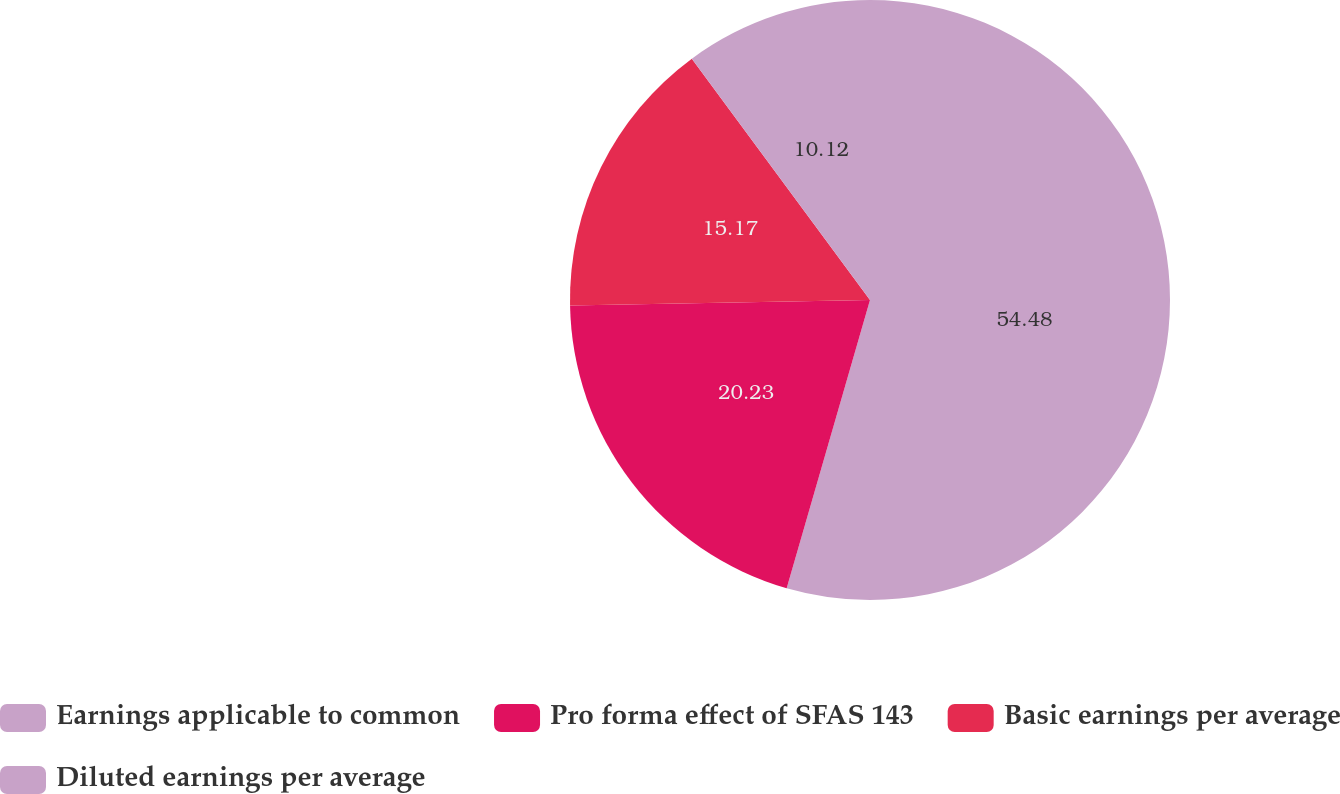Convert chart. <chart><loc_0><loc_0><loc_500><loc_500><pie_chart><fcel>Earnings applicable to common<fcel>Pro forma effect of SFAS 143<fcel>Basic earnings per average<fcel>Diluted earnings per average<nl><fcel>54.48%<fcel>20.23%<fcel>15.17%<fcel>10.12%<nl></chart> 